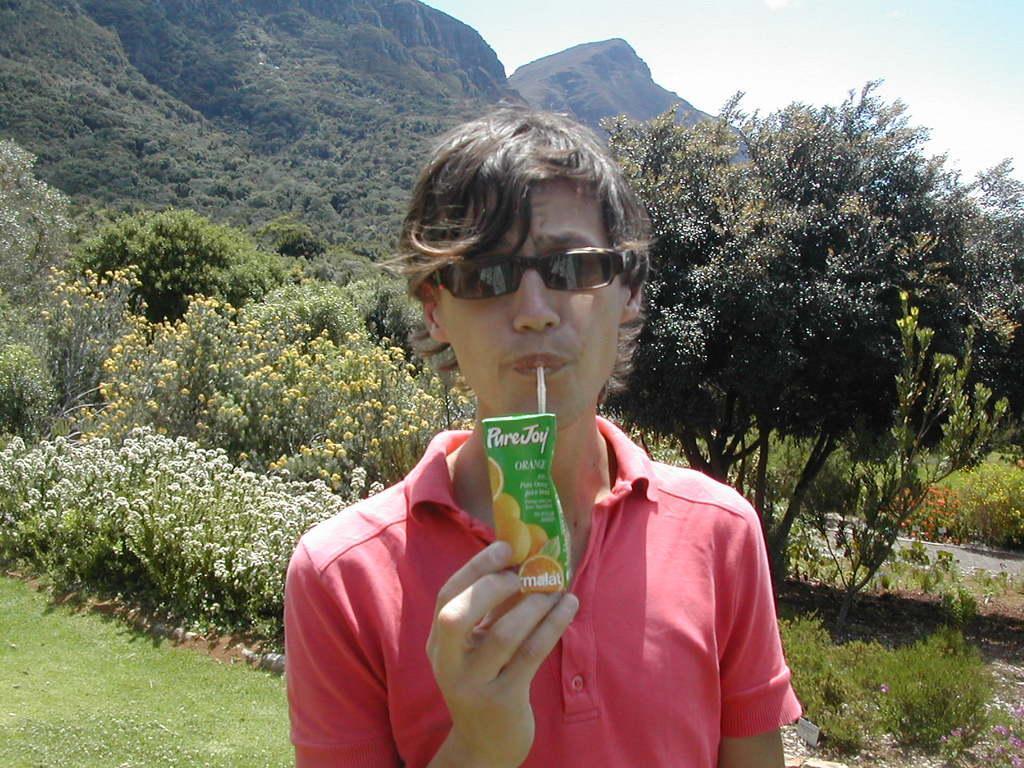Describe this image in one or two sentences. In this picture, we can see a person is drinking, we can see the ground with grass, plants, flowers, trees, mountains, road, and the sky. 